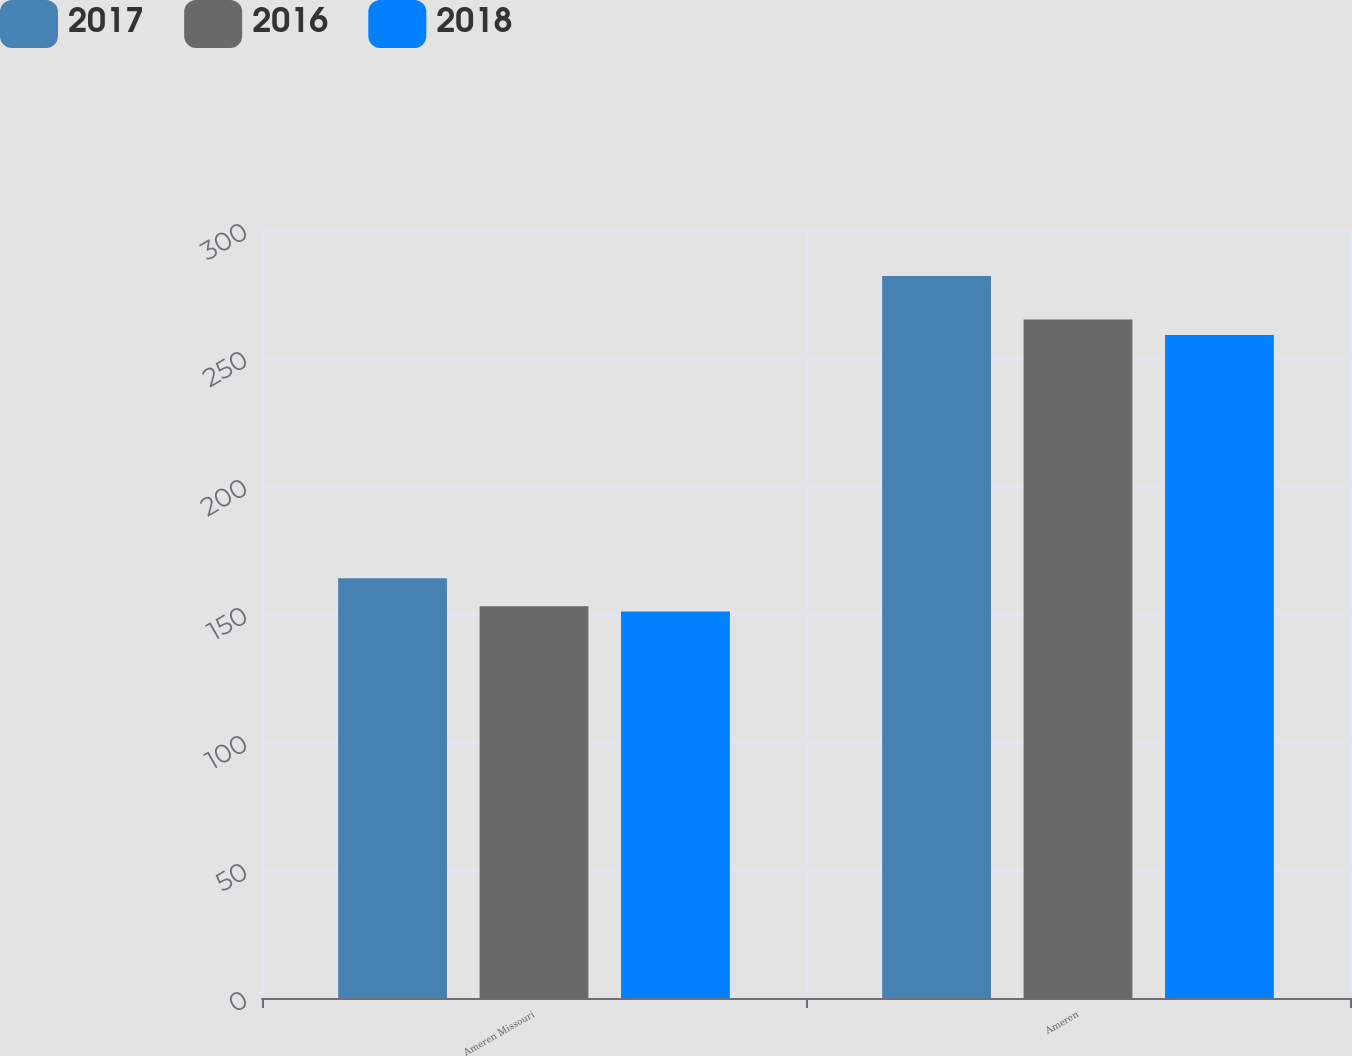Convert chart to OTSL. <chart><loc_0><loc_0><loc_500><loc_500><stacked_bar_chart><ecel><fcel>Ameren Missouri<fcel>Ameren<nl><fcel>2017<fcel>164<fcel>282<nl><fcel>2016<fcel>153<fcel>265<nl><fcel>2018<fcel>151<fcel>259<nl></chart> 